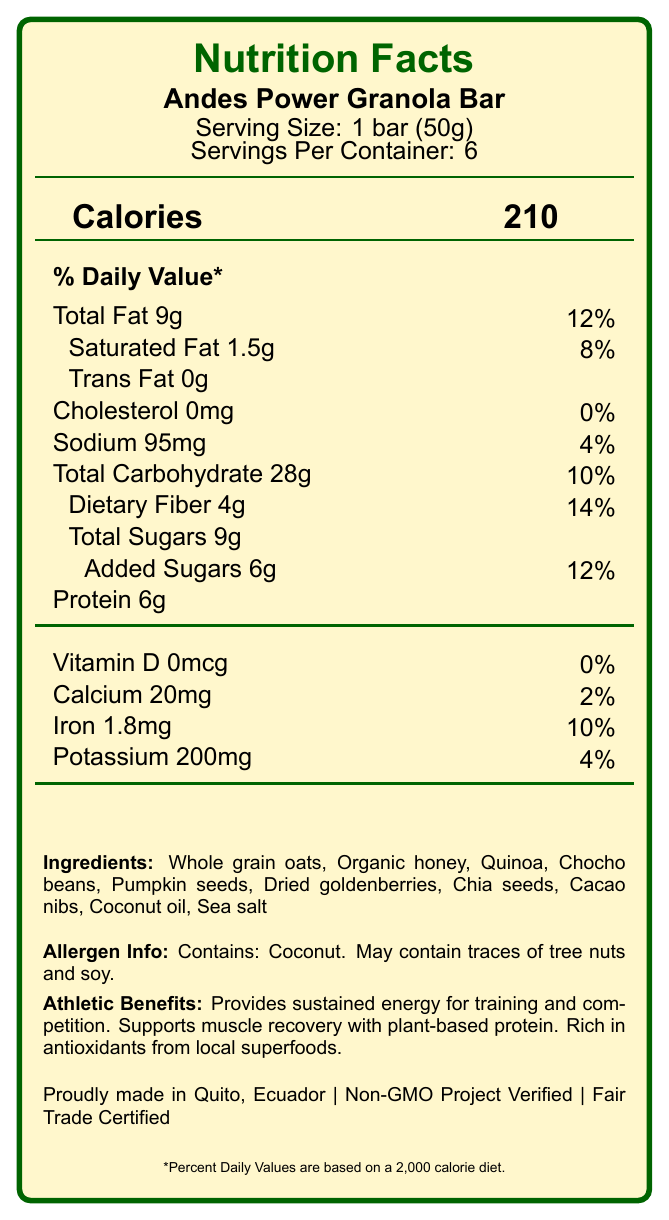what is the serving size? The document specifies the serving size as "1 bar (50g)" under the product name "Andes Power Granola Bar".
Answer: 1 bar (50g) how many servings are in each container? The document lists "Servings Per Container: 6" below the serving size information.
Answer: 6 how many calories are in one serving? The calories per serving are prominently displayed as "Calories 210" in the document.
Answer: 210 what is the total fat content in one bar? The total fat content is listed as "Total Fat 9g" in the document.
Answer: 9g what ingredients are used in the Andes Power Granola Bar? The ingredients are detailed in the "Ingredients" section of the document.
Answer: Whole grain oats, Organic honey, Quinoa, Chocho beans, Pumpkin seeds, Dried goldenberries, Chia seeds, Cacao nibs, Coconut oil, Sea salt what is the percentage daily value of dietary fiber? The dietary fiber content is listed as 4g with a 14% daily value in the document.
Answer: 14% what is the total carbohydrate content? A. 5g B. 15g C. 28g D. 45g The document states "Total Carbohydrate 28g" with a daily value of 10%.
Answer: C. 28g which ingredient listed contains potential allergens? A. Whole grain oats B. Quinoa C. Coconut oil D. Sea salt The allergen information section specifies that the product "Contains: Coconut".
Answer: C. Coconut oil does the bar contain any cholesterol? The document lists "Cholesterol 0mg" indicating there is no cholesterol in the product.
Answer: No how much protein is in each bar? The amount of protein per serving is listed as "Protein 6g".
Answer: 6g is there any added sugar in the granola bar? The document specifies "Added Sugars 6g" indicating there are added sugars.
Answer: Yes what are the athletic benefits of this granola bar? The "Athletic Benefits" section lists these three benefits.
Answer: Provides sustained energy for training and competition, Supports muscle recovery with plant-based protein, Rich in antioxidants from local superfoods where is the Andes Power Granola Bar made? The origin information specifies "Proudly made in Quito, Ecuador".
Answer: Quito, Ecuador does the packaging claim eco-friendly materials? It mentions "Wrapper made from compostable materials".
Answer: Yes what percent daily value of iron does the bar offer? The document lists the iron content as "Iron 1.8mg" with a daily value of 10%.
Answer: 10% what certifications does the product have? These certifications are mentioned at the bottom of the document.
Answer: Non-GMO Project Verified, Fair Trade Certified which component has the highest percentage of daily value? Among all the listed nutrients, Total Fat has the highest percentage of daily value at 12%.
Answer: Total Fat What is the main idea of this Nutrition Facts Label? The document details the nutritional content, ingredients, athletic benefits, origin, and eco-friendly aspects of the Andes Power Granola Bar. It emphasizes its suitability for athletes and its certifications.
Answer: The Andes Power Granola Bar is a nutritious snack designed for athletes, offering energy, plant-based protein, and antioxidants, made from locally-sourced ingredients in Quito, Ecuador with eco-friendly packaging and verified certifications. how is the bar beneficial for muscle recovery? The document lists "Supports muscle recovery with plant-based protein" under athletic benefits.
Answer: Supports muscle recovery with plant-based protein how much vitamin D does each bar provide? The document lists "Vitamin D 0mcg" indicating there is no vitamin D content in the bar.
Answer: 0mcg what is the main source of antioxidants in the bar? The athletic benefits mention that the bar is "Rich in antioxidants from local superfoods".
Answer: Local superfoods What is the granola bar's sodium content? The document lists "Sodium 95mg" with a daily value of 4%.
Answer: 95mg what is the total sugar content? The total sugars in the granola bar amount to "Total Sugars 9g".
Answer: 9g what is the calorie count if I eat two bars? Since one bar contains 210 calories, consuming two bars would double the calorie count to (210 * 2 = 420).
Answer: 420 Does this product contain any artificial preservatives? The health claims section mentions "No artificial preservatives".
Answer: No 